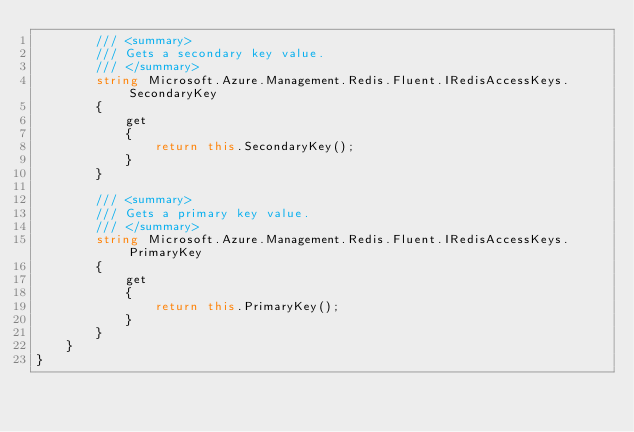<code> <loc_0><loc_0><loc_500><loc_500><_C#_>        /// <summary>
        /// Gets a secondary key value.
        /// </summary>
        string Microsoft.Azure.Management.Redis.Fluent.IRedisAccessKeys.SecondaryKey
        {
            get
            {
                return this.SecondaryKey();
            }
        }

        /// <summary>
        /// Gets a primary key value.
        /// </summary>
        string Microsoft.Azure.Management.Redis.Fluent.IRedisAccessKeys.PrimaryKey
        {
            get
            {
                return this.PrimaryKey();
            }
        }
    }
}</code> 